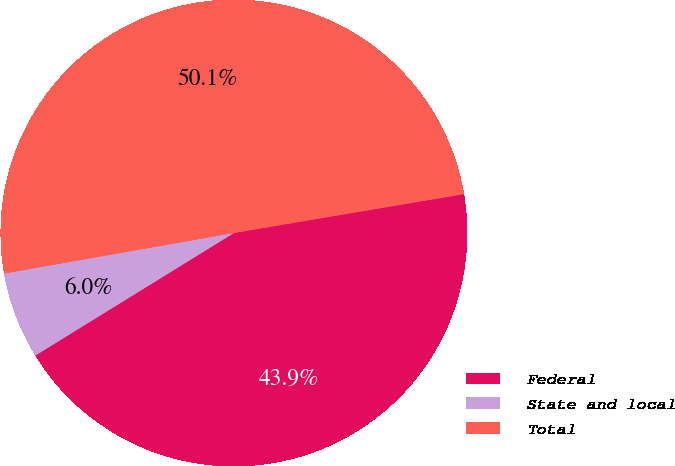<chart> <loc_0><loc_0><loc_500><loc_500><pie_chart><fcel>Federal<fcel>State and local<fcel>Total<nl><fcel>43.86%<fcel>6.02%<fcel>50.11%<nl></chart> 